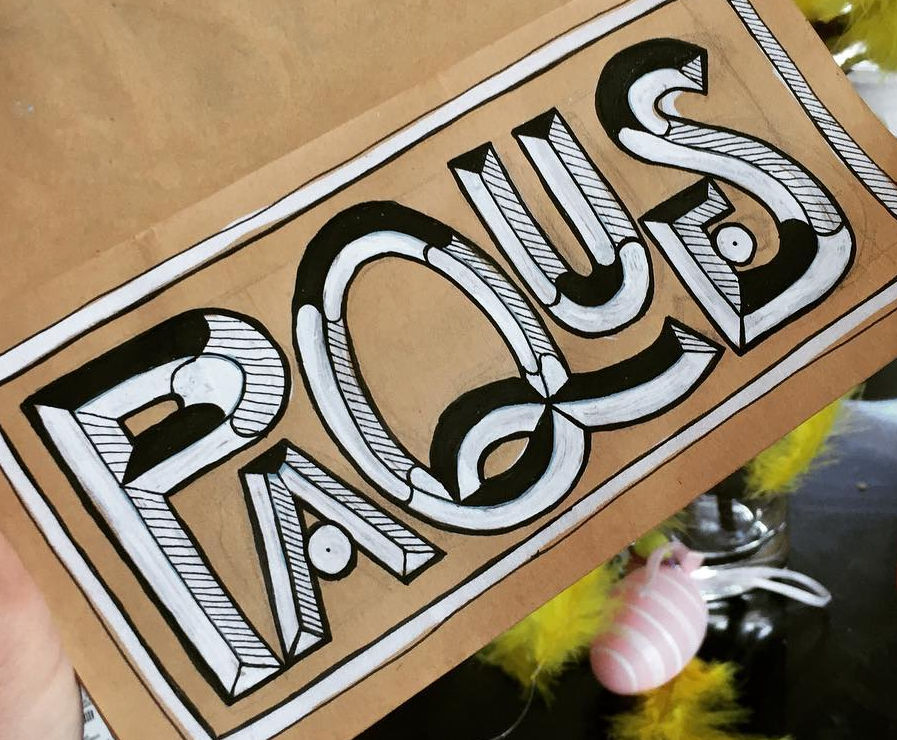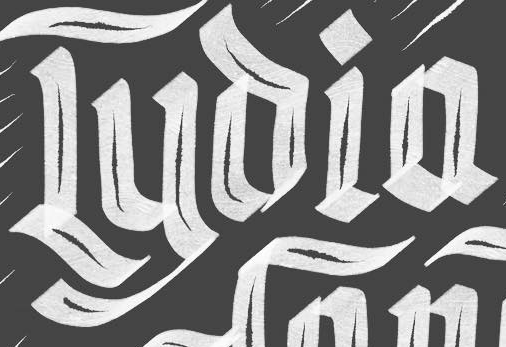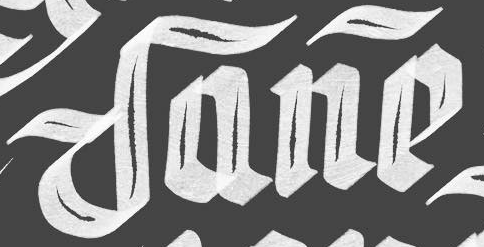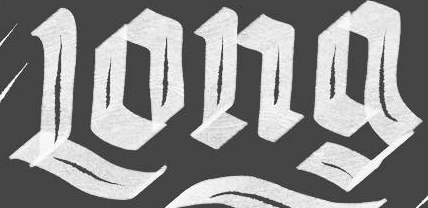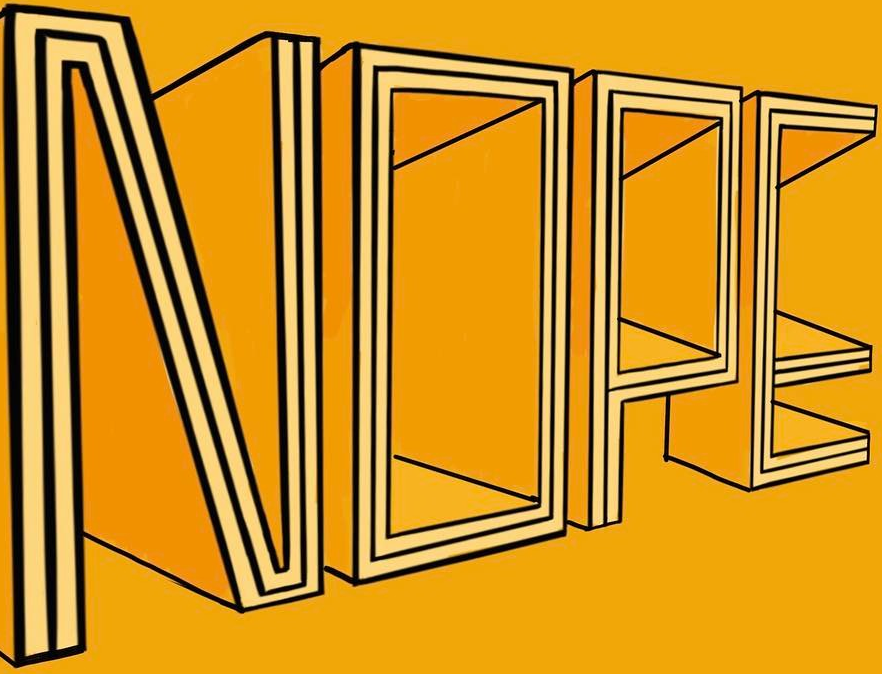Transcribe the words shown in these images in order, separated by a semicolon. PAQUES; Lyoia; Dane; Long; NOPE 